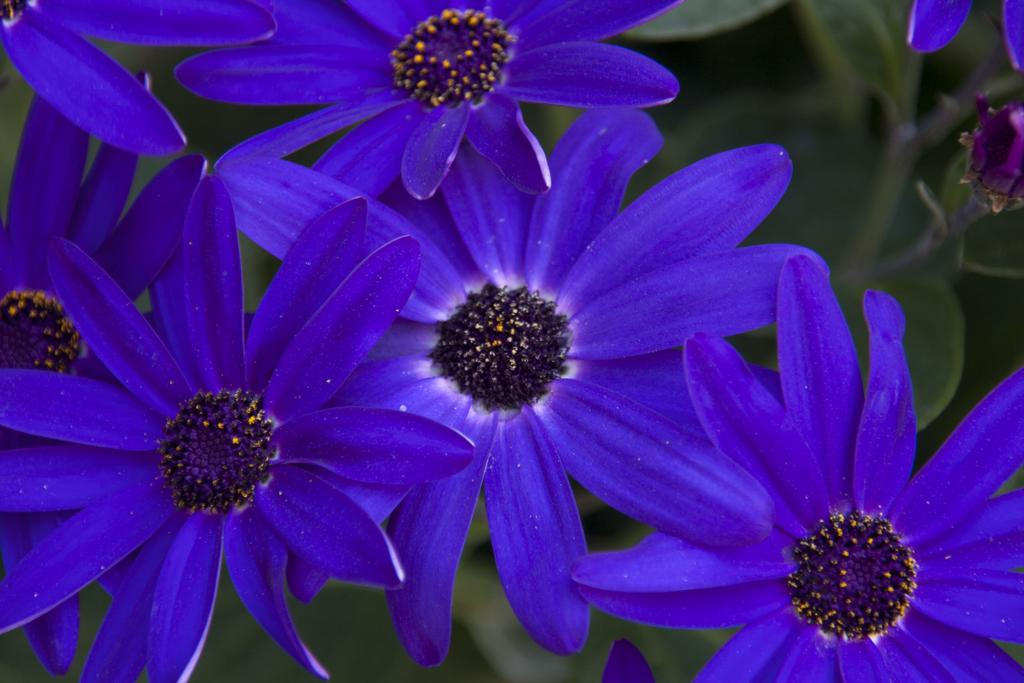What type of living organisms can be seen in the image? Flowers and plants can be seen in the image. Can you describe the colors of the flowers in the image? The colors of the flowers in the image cannot be determined without more specific information. What is the caption written on the image? There is no caption present in the image; it only contains flowers and plants. How does the wind affect the flowers in the image? The image does not show any wind or its effects on the flowers; it only shows the flowers and plants. 